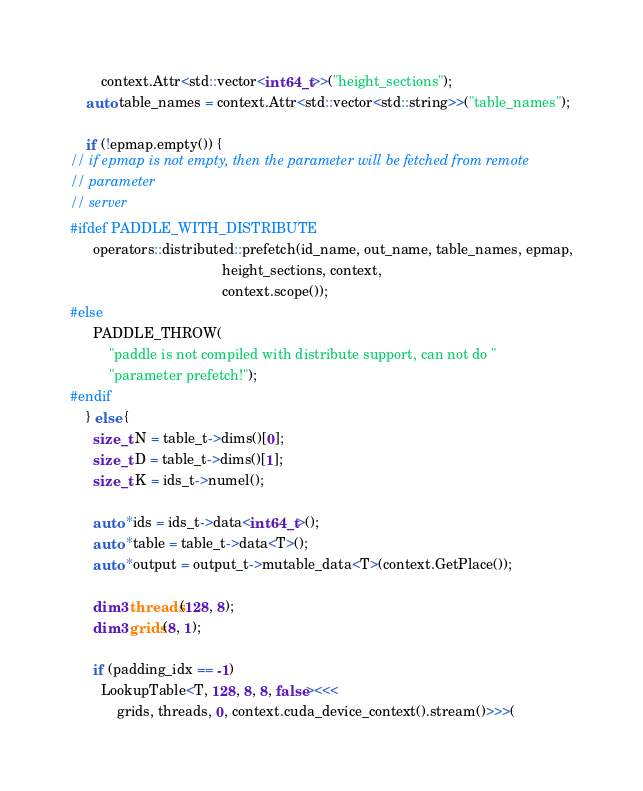<code> <loc_0><loc_0><loc_500><loc_500><_Cuda_>        context.Attr<std::vector<int64_t>>("height_sections");
    auto table_names = context.Attr<std::vector<std::string>>("table_names");

    if (!epmap.empty()) {
// if epmap is not empty, then the parameter will be fetched from remote
// parameter
// server
#ifdef PADDLE_WITH_DISTRIBUTE
      operators::distributed::prefetch(id_name, out_name, table_names, epmap,
                                       height_sections, context,
                                       context.scope());
#else
      PADDLE_THROW(
          "paddle is not compiled with distribute support, can not do "
          "parameter prefetch!");
#endif
    } else {
      size_t N = table_t->dims()[0];
      size_t D = table_t->dims()[1];
      size_t K = ids_t->numel();

      auto *ids = ids_t->data<int64_t>();
      auto *table = table_t->data<T>();
      auto *output = output_t->mutable_data<T>(context.GetPlace());

      dim3 threads(128, 8);
      dim3 grids(8, 1);

      if (padding_idx == -1)
        LookupTable<T, 128, 8, 8, false><<<
            grids, threads, 0, context.cuda_device_context().stream()>>>(</code> 